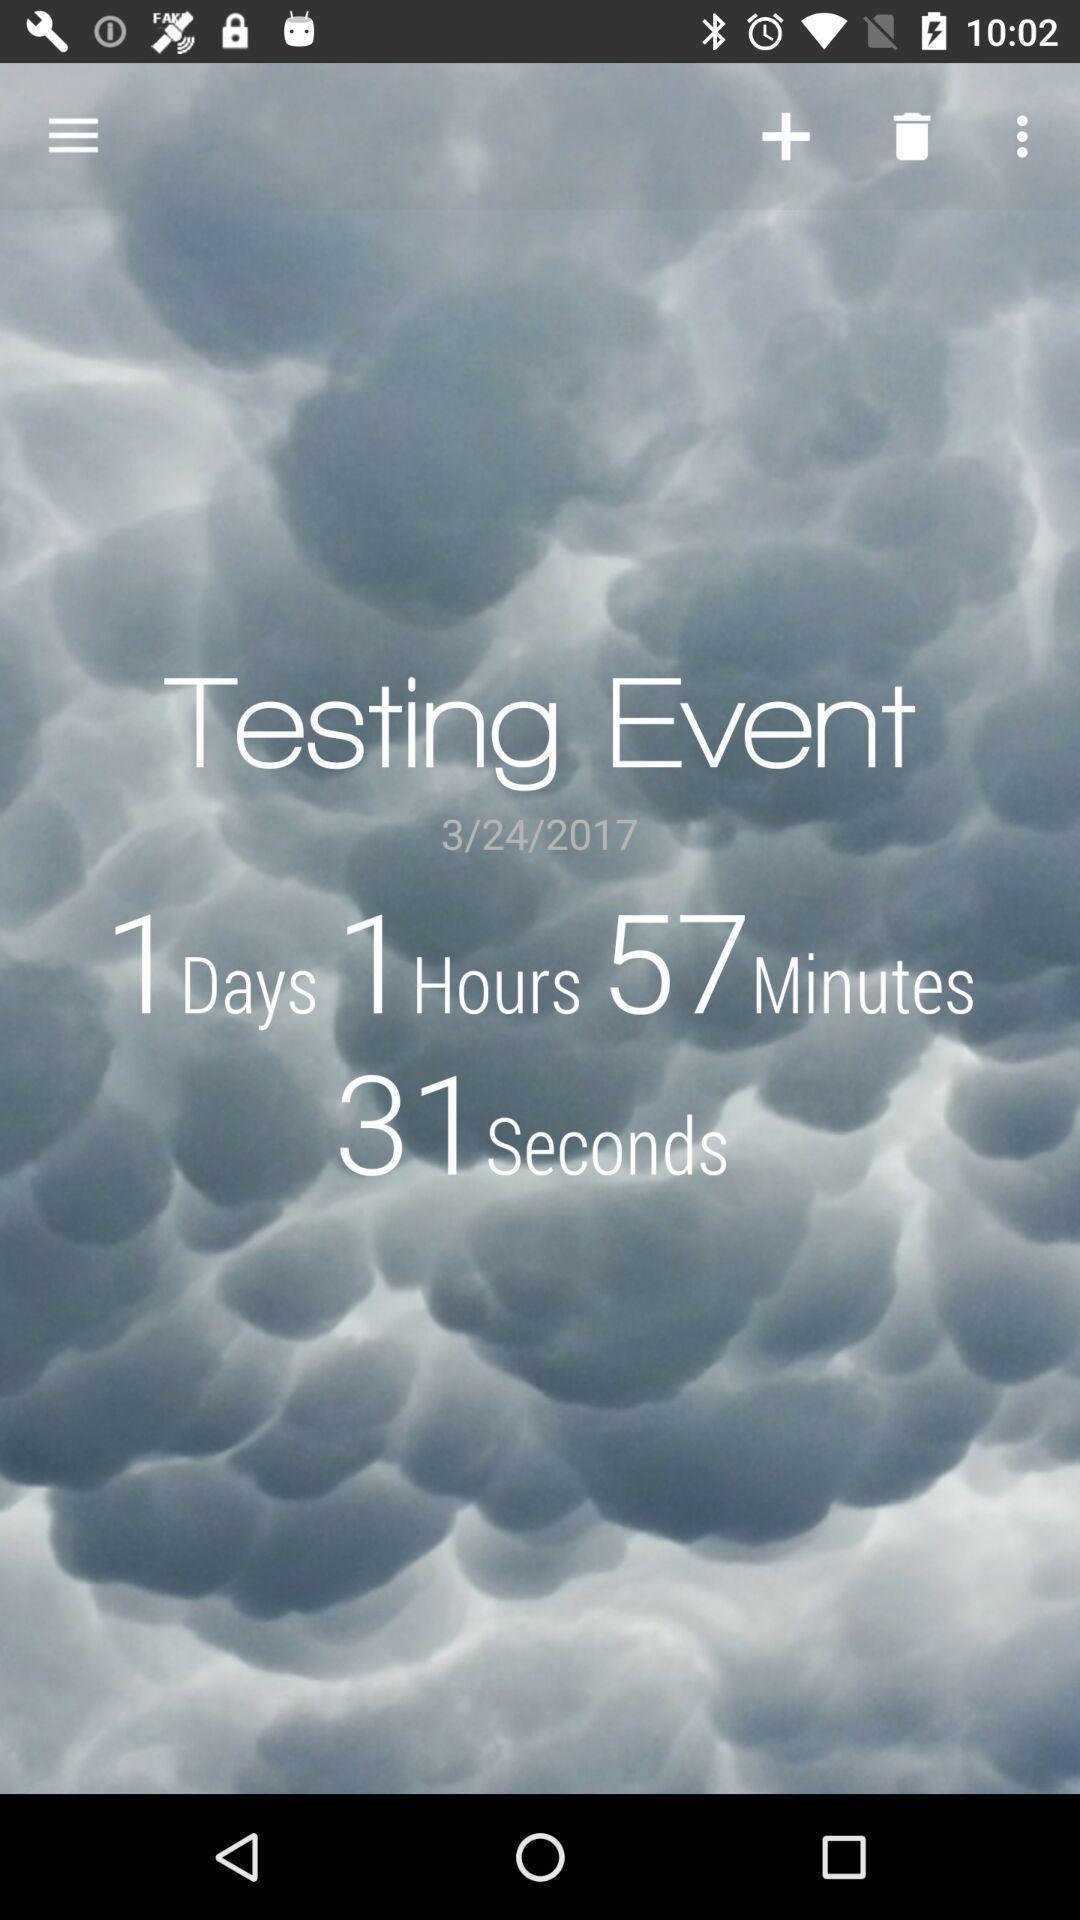What is the overall content of this screenshot? Page showing testing event with date and time in application. 